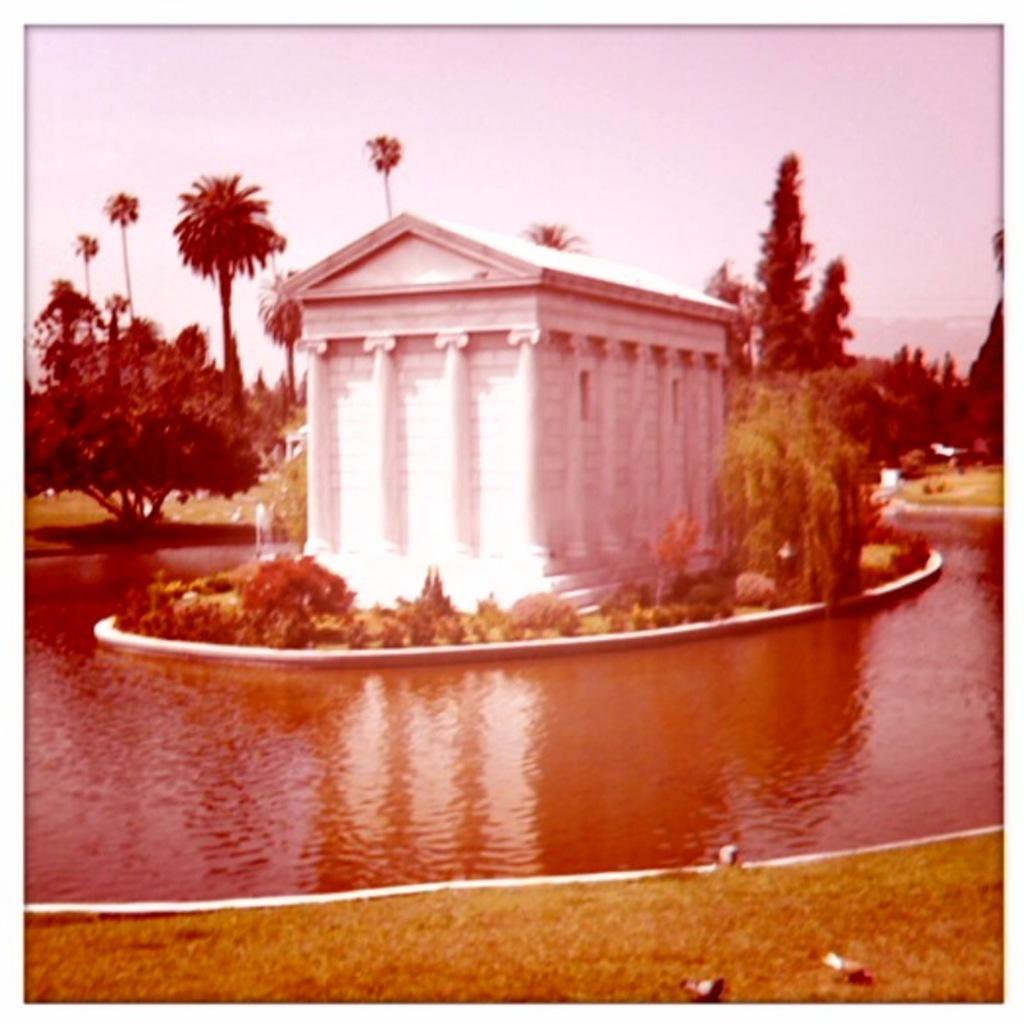Can you describe this image briefly? In this image there is a pound, in middle there is a house, in the background there are trees and there is a sky. 